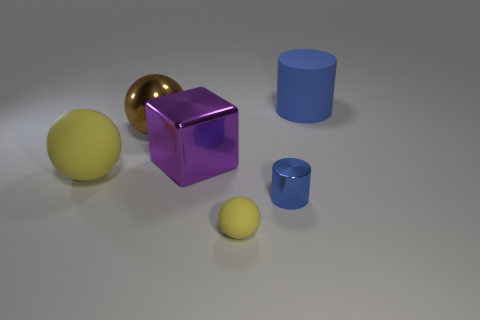Subtract all big balls. How many balls are left? 1 Add 3 tiny yellow spheres. How many objects exist? 9 Subtract all blocks. How many objects are left? 5 Subtract 1 purple cubes. How many objects are left? 5 Subtract all tiny blue things. Subtract all small yellow matte objects. How many objects are left? 4 Add 5 matte balls. How many matte balls are left? 7 Add 4 purple matte cylinders. How many purple matte cylinders exist? 4 